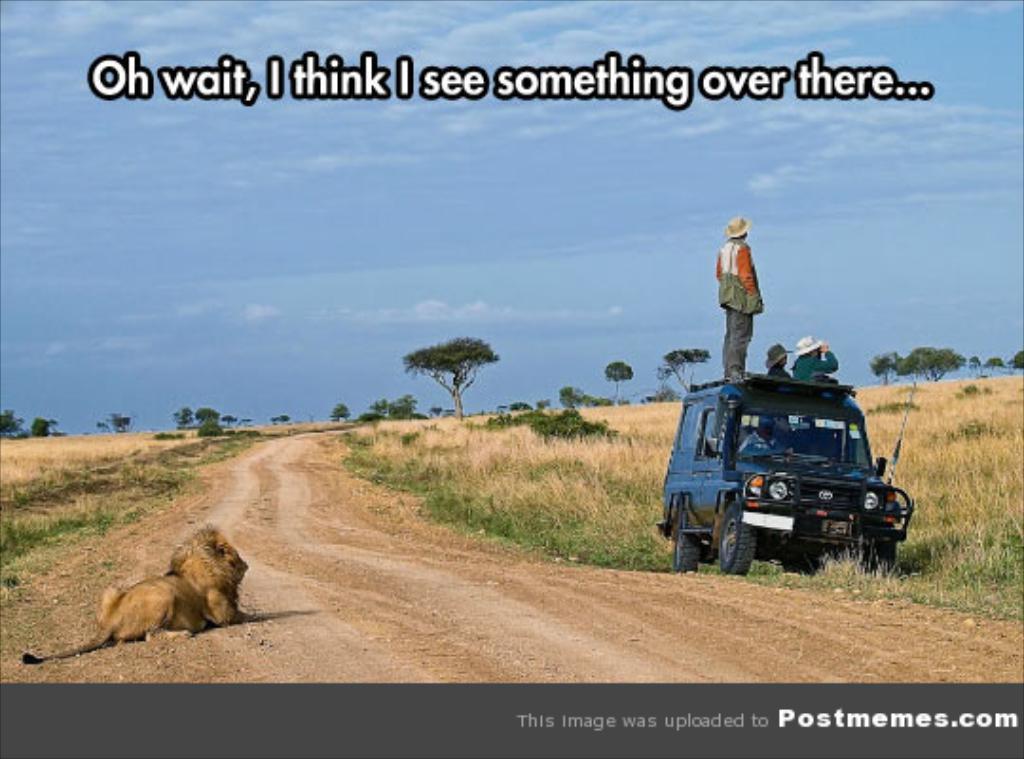In one or two sentences, can you explain what this image depicts? Here, we can see a picture, on that picture at the left side there is a lion sitting on the ground, at the right side there is a black color car, there is a person standing on the car, in the background there are some green color trees, at the top there is a blue color sky. 